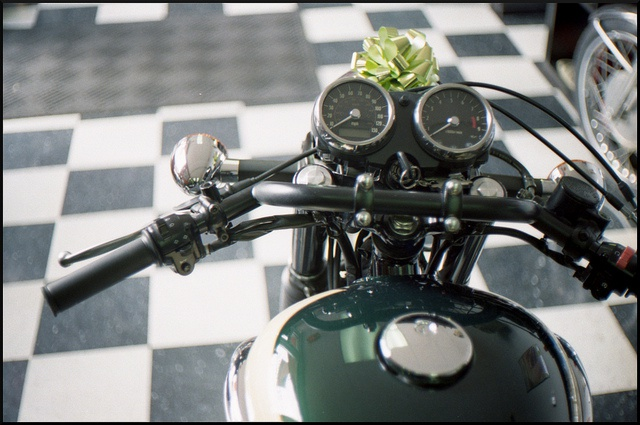Describe the objects in this image and their specific colors. I can see motorcycle in black, gray, lightgray, and darkgray tones, bicycle in black, darkgray, gray, and lightgray tones, and motorcycle in black, darkgray, gray, and lightgray tones in this image. 